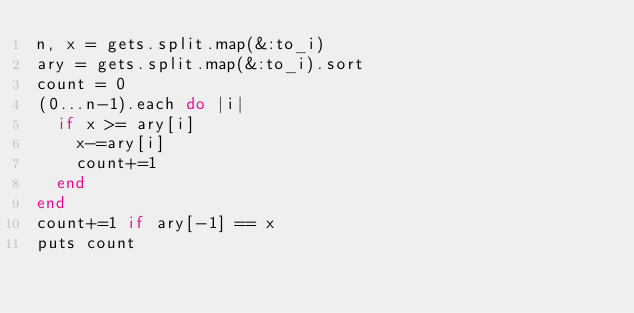<code> <loc_0><loc_0><loc_500><loc_500><_Ruby_>n, x = gets.split.map(&:to_i)
ary = gets.split.map(&:to_i).sort
count = 0
(0...n-1).each do |i|
  if x >= ary[i]
    x-=ary[i]
    count+=1
  end
end
count+=1 if ary[-1] == x
puts count
</code> 